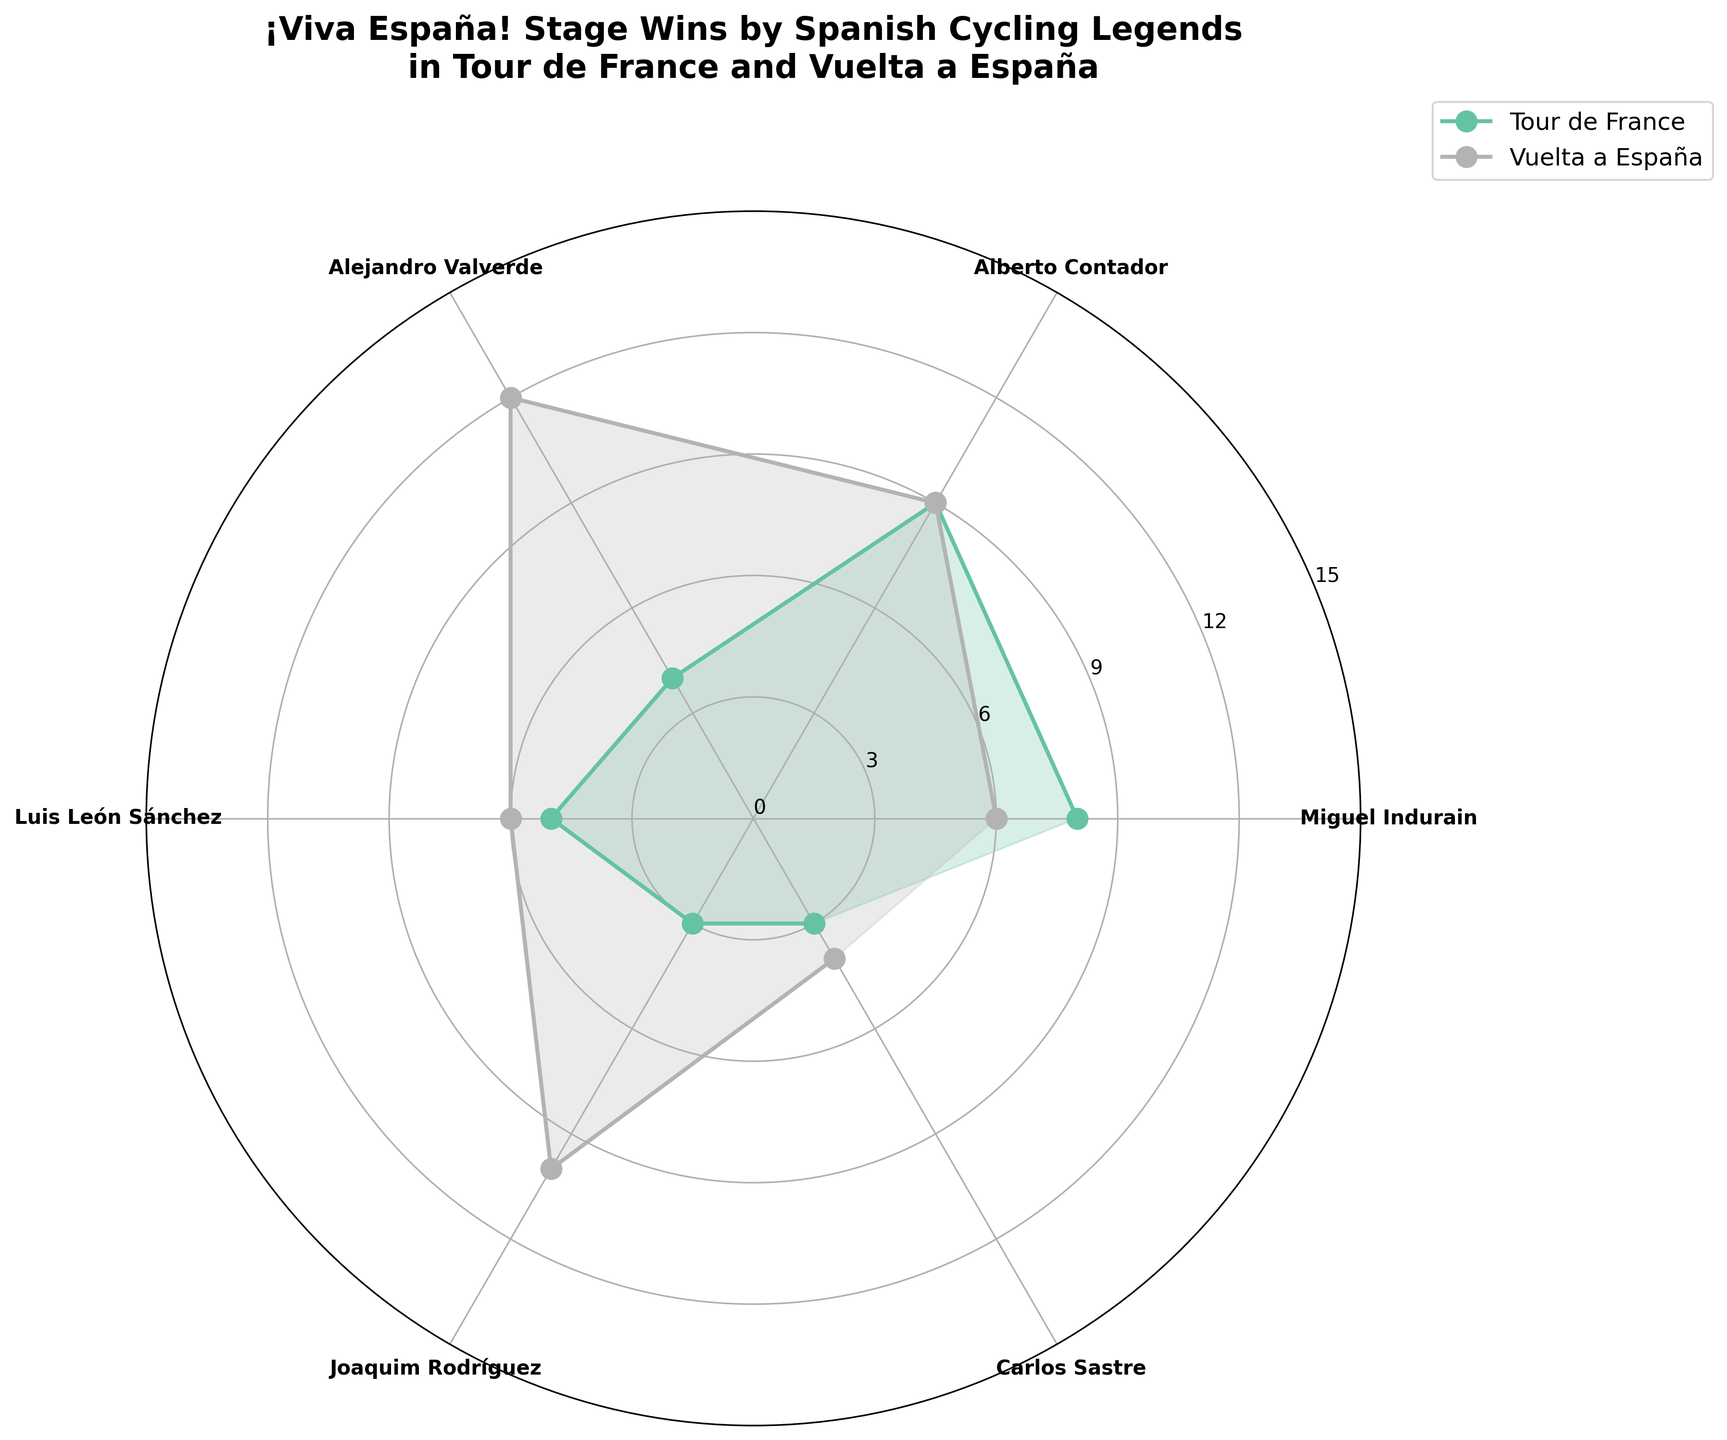What's the title of this chart? The title is located at the top of the figure, usually in a bold font. Just reading it directly from the figure gives us the answer.
Answer: ¡Viva España! Stage Wins by Spanish Cycling Legends in Tour de France and Vuelta a España How many stage wins does Alejandro Valverde have in the Vuelta a España? On the rose chart, each cyclist's segment is marked with labels, and their performance in each event is shown with different colored lines. Look for Alejandro Valverde and check the value for the Vuelta a España.
Answer: 12 Which event has the highest total stage wins by Spanish cyclists, Tour de France or Vuelta a España? Sum the stage wins for each event across all cyclists. Look at the lengths of the corresponding lines in the chart for each cyclist and add them up for each event.
Answer: Vuelta a España How many cyclists are represented in this chart? The number of unique labels (cyclist names) on the outer circle of the rose chart indicates the number of cyclists.
Answer: 5 Who has more stage wins in the Tour de France, Alberto Contador or Miguel Indurain? Compare the length of the colored line for the Tour de France event for both Alberto Contador and Miguel Indurain on the rose plot.
Answer: Alberto Contador What is the average number of stage wins for Luis León Sánchez across both events? Luis León Sánchez's stage wins in the Tour de France and Vuelta a España can be found by checking the corresponding segments. Add these values and divide by 2 for the average.
Answer: 5.5 Which cyclist has the least number of stage wins in the Tour de France? Examine each cyclist’s segment and look for the smallest value corresponding to the Tour de France event.
Answer: Joaquim Rodríguez and Carlos Sastre (tie) How many events are shown in the rose chart? The chart distinguishes between different events using different colors/lines. Counting these provides the answer.
Answer: 2 Which cyclist dominates the Vuelta a España in terms of stage wins? Look for the cyclist whose segment line for the Vuelta a España reaches the highest value on the rose chart.
Answer: Alejandro Valverde What's the difference in stage wins between Joaquim Rodríguez in the Tour de France and Vuelta a España? Identify Joaquim Rodríguez’s stage wins in both events from the segments on the rose chart and calculate the difference.
Answer: 7 